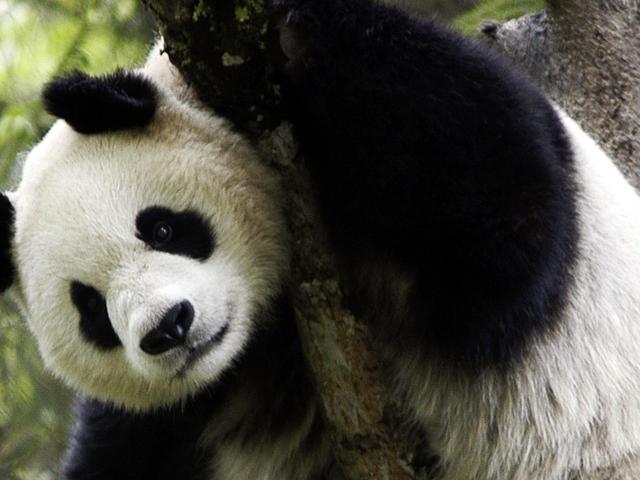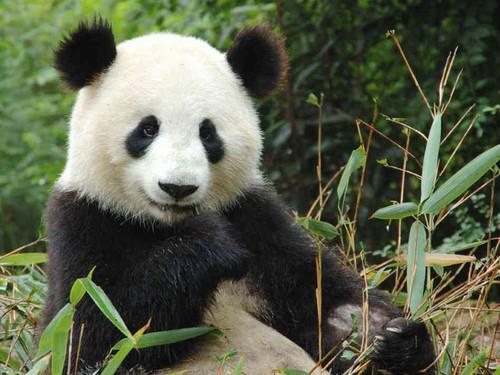The first image is the image on the left, the second image is the image on the right. For the images displayed, is the sentence "Panda in the right image is nibbling something." factually correct? Answer yes or no. Yes. 